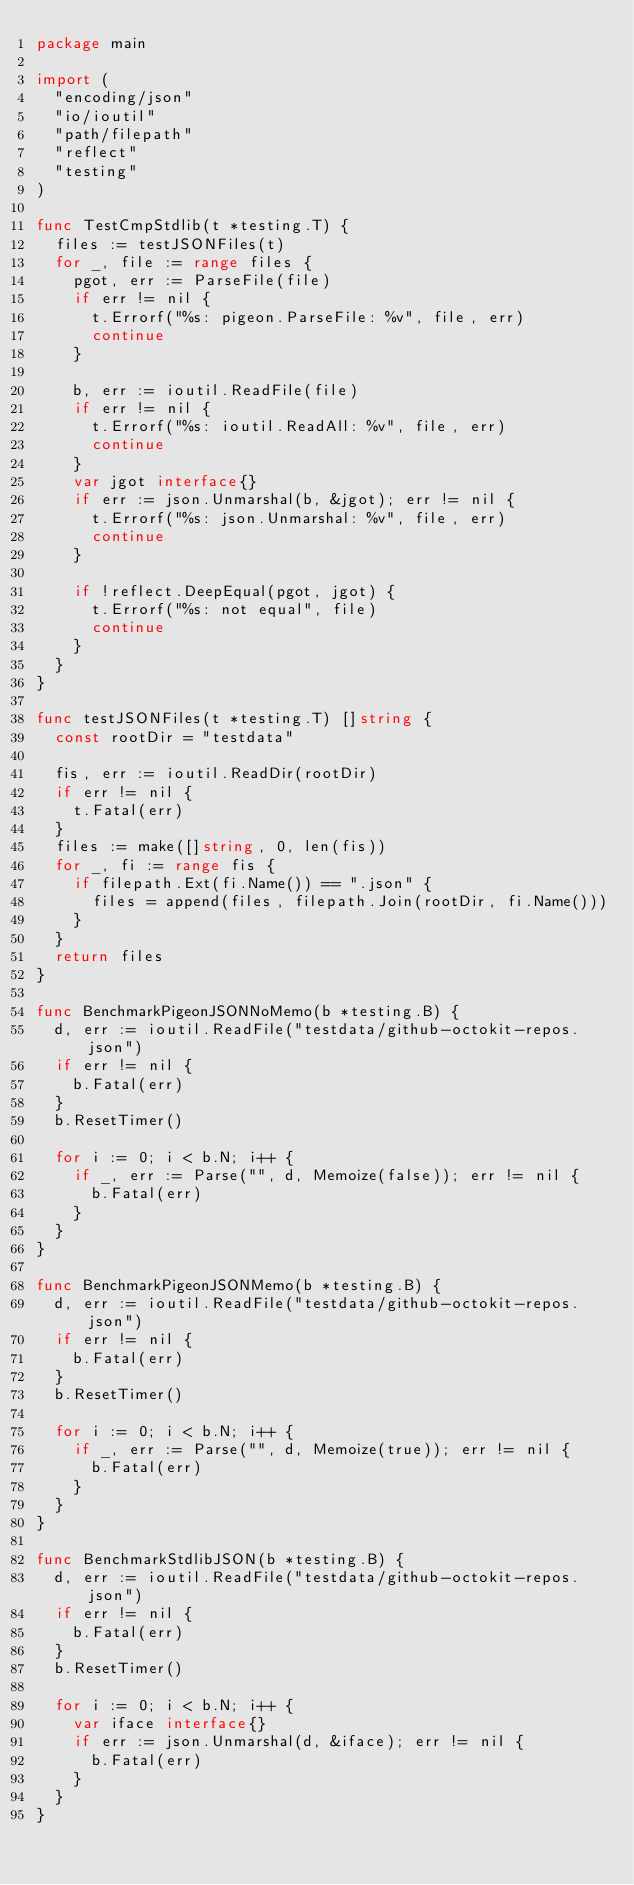<code> <loc_0><loc_0><loc_500><loc_500><_Go_>package main

import (
	"encoding/json"
	"io/ioutil"
	"path/filepath"
	"reflect"
	"testing"
)

func TestCmpStdlib(t *testing.T) {
	files := testJSONFiles(t)
	for _, file := range files {
		pgot, err := ParseFile(file)
		if err != nil {
			t.Errorf("%s: pigeon.ParseFile: %v", file, err)
			continue
		}

		b, err := ioutil.ReadFile(file)
		if err != nil {
			t.Errorf("%s: ioutil.ReadAll: %v", file, err)
			continue
		}
		var jgot interface{}
		if err := json.Unmarshal(b, &jgot); err != nil {
			t.Errorf("%s: json.Unmarshal: %v", file, err)
			continue
		}

		if !reflect.DeepEqual(pgot, jgot) {
			t.Errorf("%s: not equal", file)
			continue
		}
	}
}

func testJSONFiles(t *testing.T) []string {
	const rootDir = "testdata"

	fis, err := ioutil.ReadDir(rootDir)
	if err != nil {
		t.Fatal(err)
	}
	files := make([]string, 0, len(fis))
	for _, fi := range fis {
		if filepath.Ext(fi.Name()) == ".json" {
			files = append(files, filepath.Join(rootDir, fi.Name()))
		}
	}
	return files
}

func BenchmarkPigeonJSONNoMemo(b *testing.B) {
	d, err := ioutil.ReadFile("testdata/github-octokit-repos.json")
	if err != nil {
		b.Fatal(err)
	}
	b.ResetTimer()

	for i := 0; i < b.N; i++ {
		if _, err := Parse("", d, Memoize(false)); err != nil {
			b.Fatal(err)
		}
	}
}

func BenchmarkPigeonJSONMemo(b *testing.B) {
	d, err := ioutil.ReadFile("testdata/github-octokit-repos.json")
	if err != nil {
		b.Fatal(err)
	}
	b.ResetTimer()

	for i := 0; i < b.N; i++ {
		if _, err := Parse("", d, Memoize(true)); err != nil {
			b.Fatal(err)
		}
	}
}

func BenchmarkStdlibJSON(b *testing.B) {
	d, err := ioutil.ReadFile("testdata/github-octokit-repos.json")
	if err != nil {
		b.Fatal(err)
	}
	b.ResetTimer()

	for i := 0; i < b.N; i++ {
		var iface interface{}
		if err := json.Unmarshal(d, &iface); err != nil {
			b.Fatal(err)
		}
	}
}
</code> 